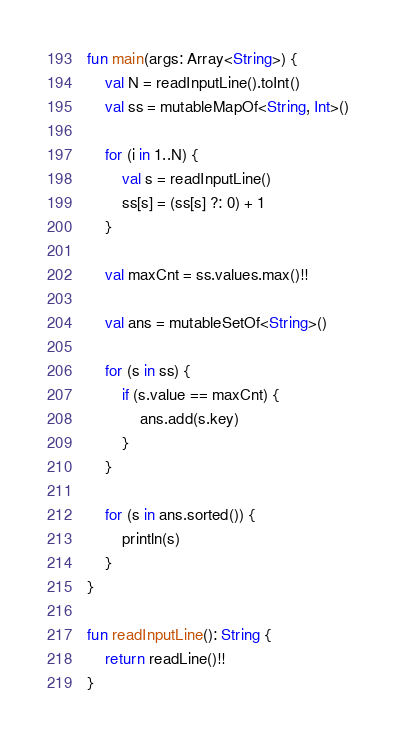Convert code to text. <code><loc_0><loc_0><loc_500><loc_500><_Kotlin_>fun main(args: Array<String>) {
    val N = readInputLine().toInt()
    val ss = mutableMapOf<String, Int>()

    for (i in 1..N) {
        val s = readInputLine()
        ss[s] = (ss[s] ?: 0) + 1
    }

    val maxCnt = ss.values.max()!!

    val ans = mutableSetOf<String>()

    for (s in ss) {
        if (s.value == maxCnt) {
            ans.add(s.key)
        }
    }

    for (s in ans.sorted()) {
        println(s)
    }
}

fun readInputLine(): String {
    return readLine()!!
}
</code> 